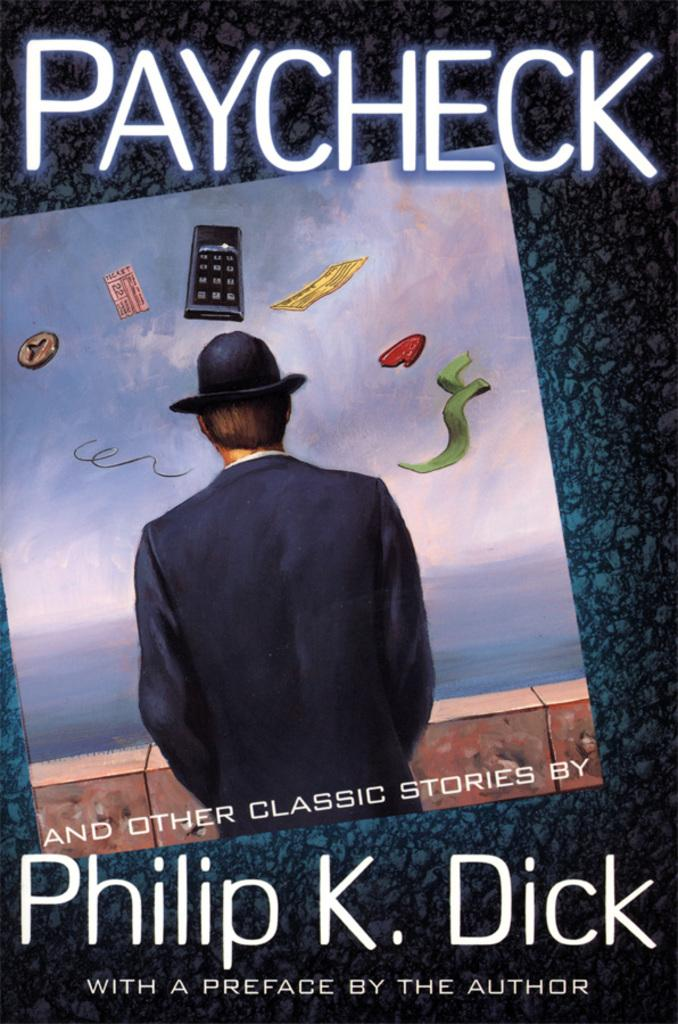<image>
Provide a brief description of the given image. the cover of the book paycheck by philip k dick. 